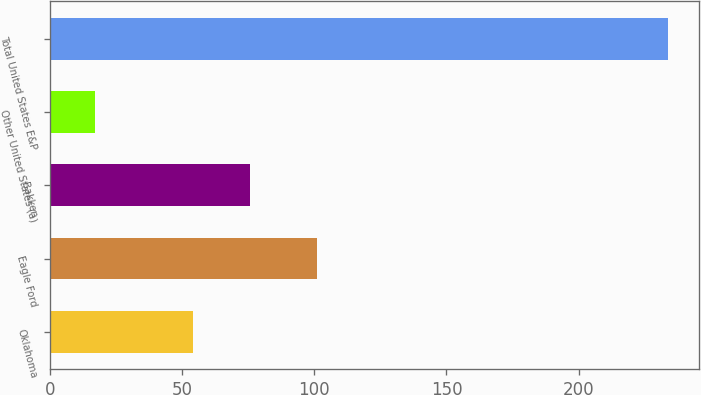Convert chart to OTSL. <chart><loc_0><loc_0><loc_500><loc_500><bar_chart><fcel>Oklahoma<fcel>Eagle Ford<fcel>Bakken<fcel>Other United States (a)<fcel>Total United States E&P<nl><fcel>54<fcel>101<fcel>75.7<fcel>17<fcel>234<nl></chart> 